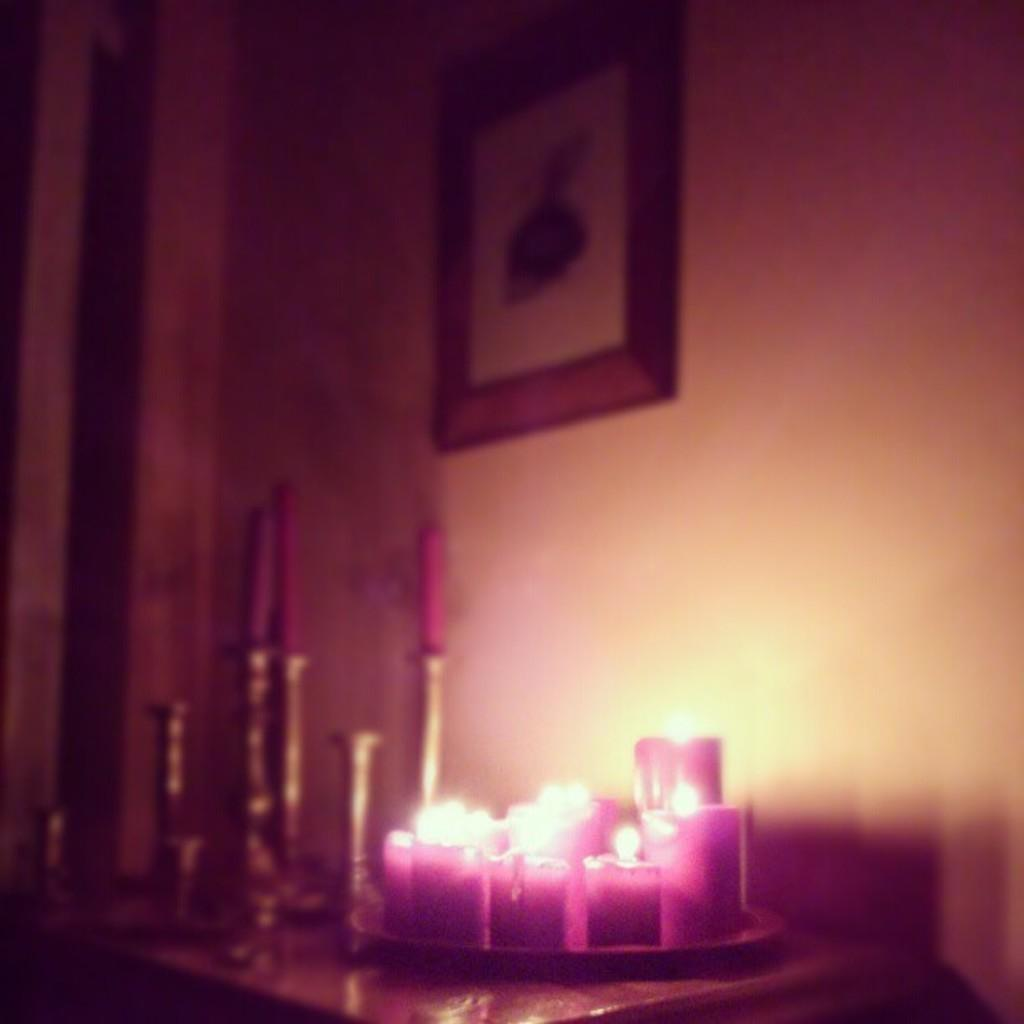What is located at the bottom of the image? There is a table at the bottom of the image. What is placed on the table? A candle stand and a plate are placed on the table. What is on the candle stand? There are candles on the table. What can be seen in the background of the image? There is a wall in the background of the image. What is attached to the wall? A frame is attached to the wall. What type of knot is used to secure the candles on the table? There is no knot used to secure the candles on the table; they are simply placed on the candle stand. 